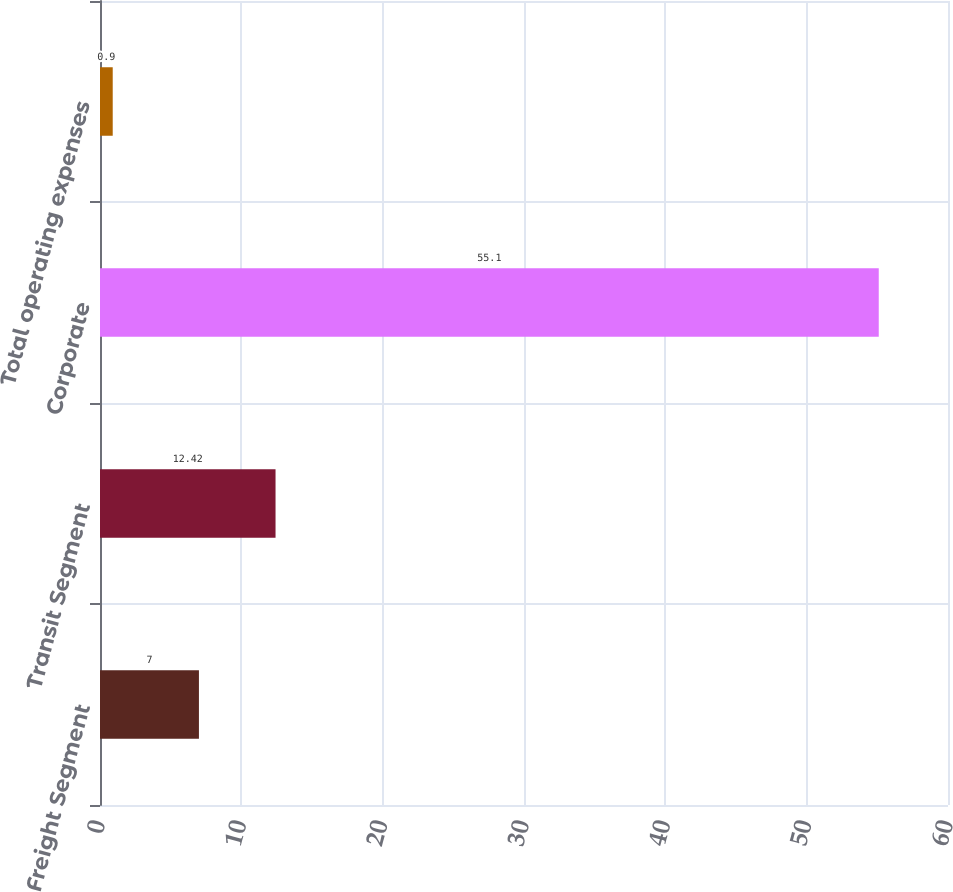Convert chart to OTSL. <chart><loc_0><loc_0><loc_500><loc_500><bar_chart><fcel>Freight Segment<fcel>Transit Segment<fcel>Corporate<fcel>Total operating expenses<nl><fcel>7<fcel>12.42<fcel>55.1<fcel>0.9<nl></chart> 